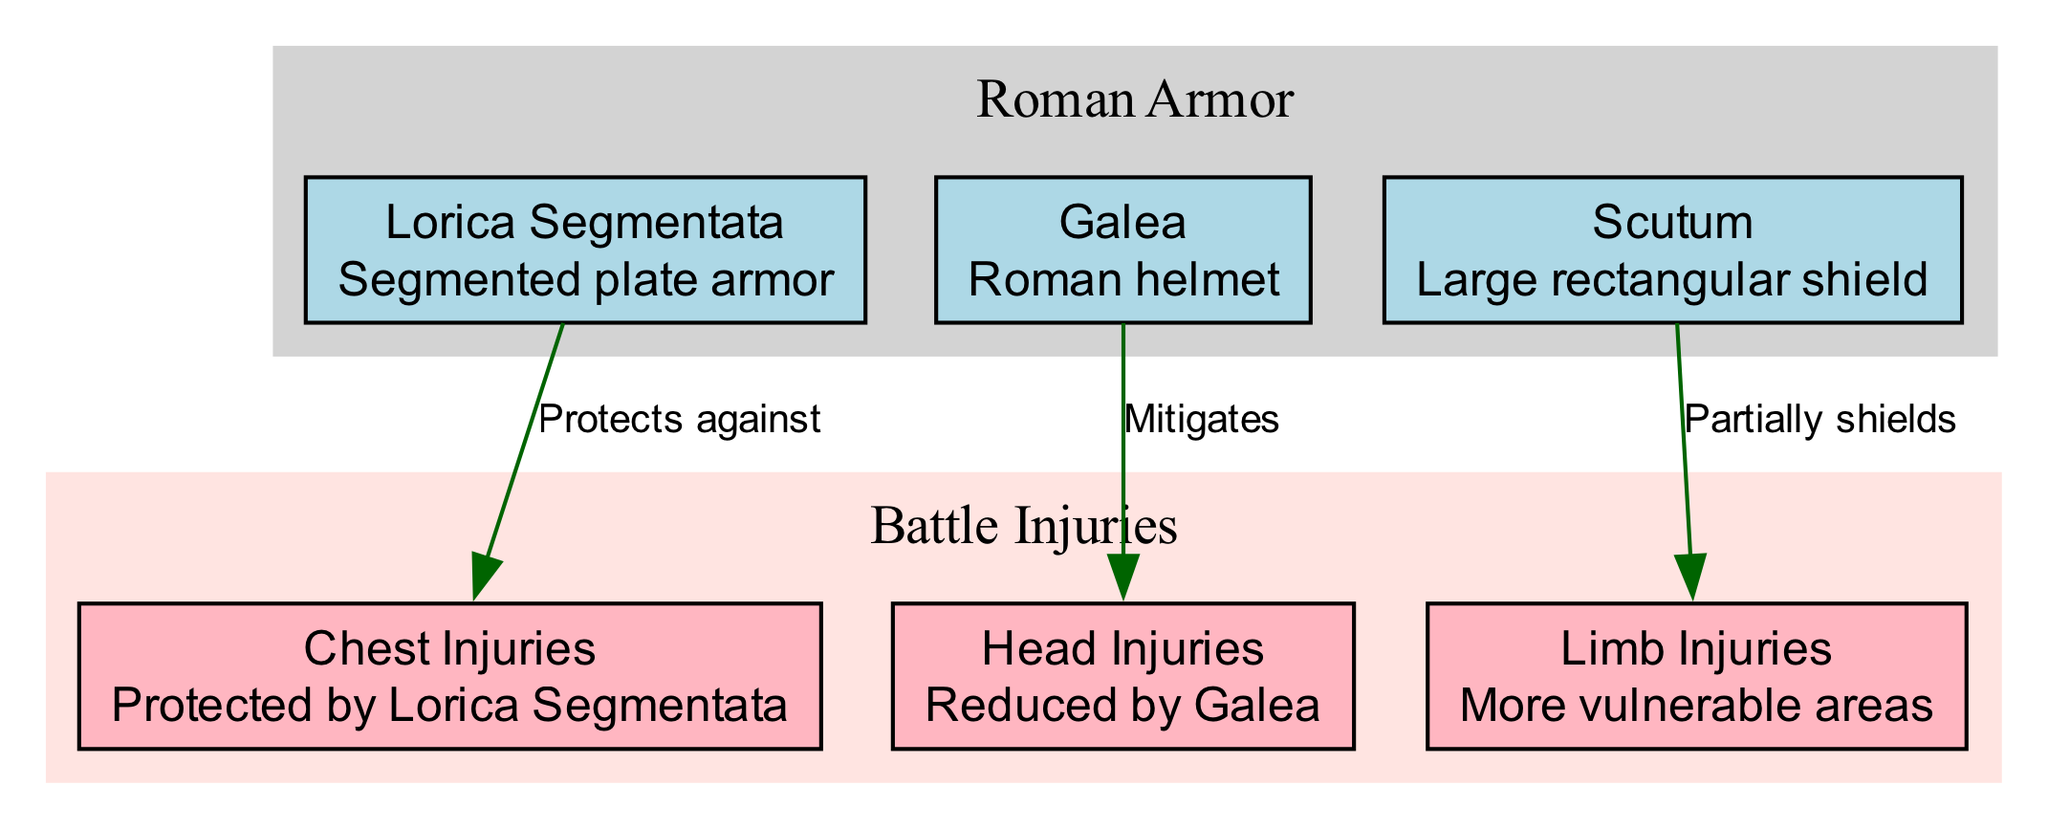What is the primary function of the Lorica Segmentata? The Lorica Segmentata is specifically described as "Segmented plate armor" which implies its main role is to protect the chest area of the soldier.
Answer: Segment protection What injuries are mitigated by the Galea? The Galea is noted as having an impact on "Head Injuries," indicating that it protects the soldier’s head during battles.
Answer: Head Injuries Which armor partially shields limb injuries? The diagram mentions that the Scutum "Partially shields" limb injuries, suggesting its role in providing some level of protection to a soldier's limbs.
Answer: Scutum How many nodes are there in the diagram? By counting all the nodes listed, there are a total of 5 nodes in the diagram, which include the different types of armor and injuries.
Answer: 5 What type of injuries does the Lorica Segmentata protect against? The description linked to Lorica Segmentata directly states it protects specifically against "Chest Injuries."
Answer: Chest Injuries Which piece of armor is associated with limb injuries? The specific association with limb injuries is explicitly indicated in the diagram, with Scutum listed as providing partial shielding.
Answer: Scutum What color represents the Battle Injuries in the diagram? The subgraph for Battle Injuries is filled with "mistyrose," clearly indicating the color scheme used for that aspect of the diagram.
Answer: Mistyrose Explain how the Lorica Segmentata and Galea collectively protect the soldier. The Lorica Segmentata protects the chest area while the Galea mitigates head injuries. Together, their protective roles create a barrier against critical injuries to vital areas of a soldier's body.
Answer: Chest and head protection 